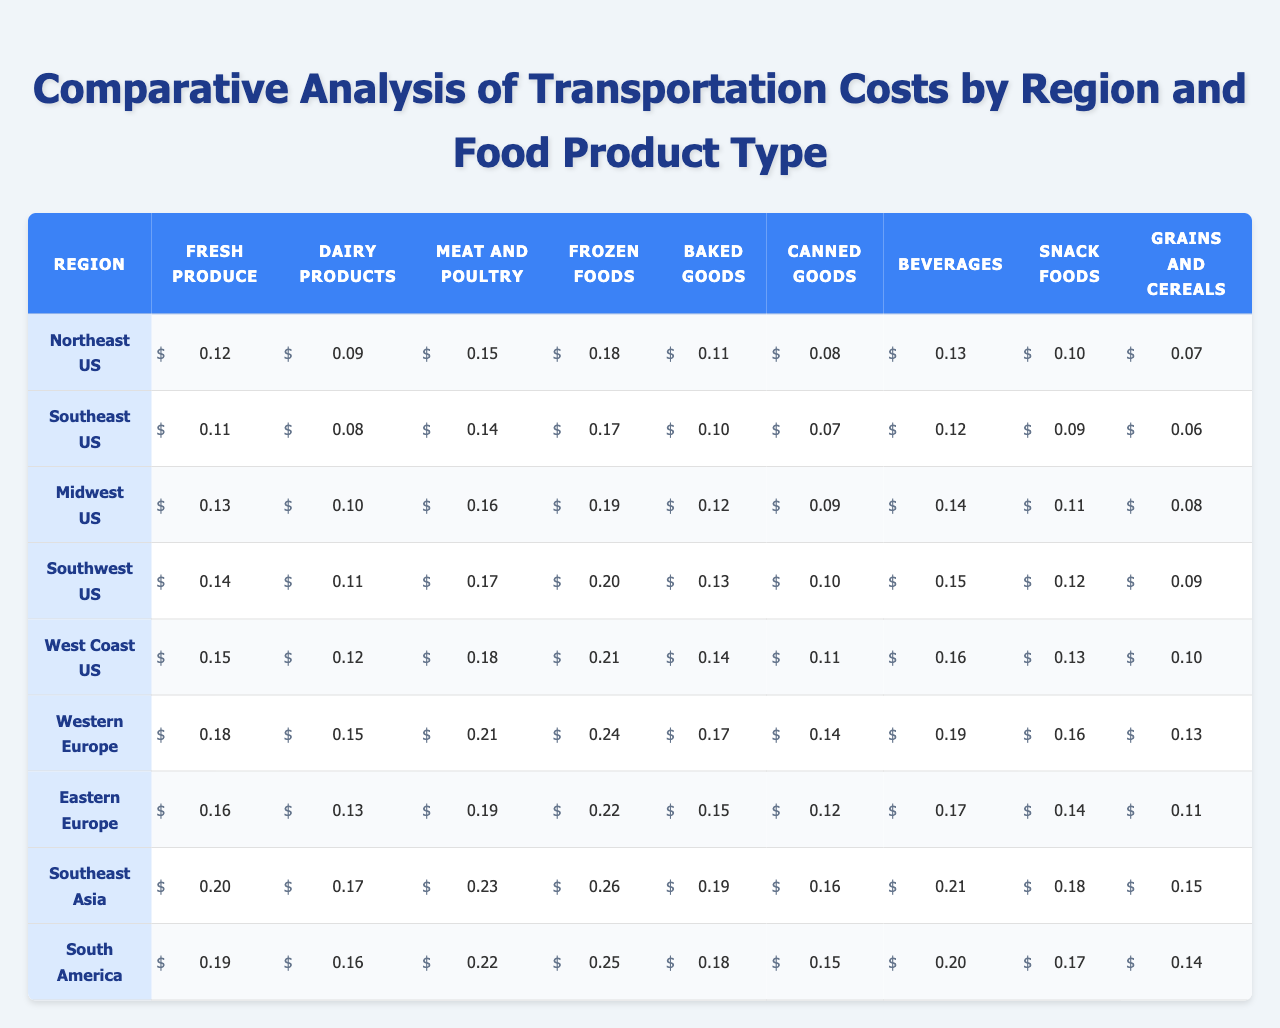What region has the highest transportation cost for Frozen Foods? In the table, we look for the row with the highest value under the "Frozen Foods" column. The "Southeast Asia" region has the highest cost at 0.26.
Answer: Southeast Asia What is the transportation cost for Dairy Products in the Midwestern US? The table indicates that the transportation cost for Dairy Products in the "Midwest US" region is 0.10.
Answer: 0.10 Which food product type has the lowest transportation cost in the Western Europe region? By examining the "Western Europe" row, we see that "Grains and Cereals" has the lowest transportation cost at 0.13.
Answer: Grains and Cereals Is the transportation cost for Baked Goods in the Northeast US higher than in the Southeast US? The table shows that the cost in the Northeast US is 0.11 and in Southeast US is 0.10. Since 0.11 is greater than 0.10, the answer is yes.
Answer: Yes What is the average transportation cost for Meat and Poultry across all regions? To find the average, we sum the values for Meat and Poultry: (0.15 + 0.14 + 0.16 + 0.17 + 0.18 + 0.21 + 0.19 + 0.23 + 0.22) = 1.45. There are 9 regions, so we divide by 9 to get an average of 1.45 / 9 = 0.1611, which rounds to 0.16.
Answer: 0.16 Which region has the highest transportation cost for Snack Foods? By examining the column for Snack Foods, we find that "Southeast Asia" shows a cost of 0.18, which is higher than others.
Answer: Southeast Asia Does the transportation cost for Canned Goods in South America exceed that in the Midwest US? The cost for Canned Goods in South America is 0.15, while in the Midwest US, it's 0.09. Since 0.15 is greater than 0.09, the answer is yes.
Answer: Yes What are the two regions with the lowest transportation costs for Fresh Produce? Looking at the Fresh Produce column, we identify the regions: Southeast US (0.11) and Midwest US (0.13), which are the lowest values.
Answer: Southeast US and Midwest US What is the difference in transportation costs for Frozen Foods between the West Coast US and Western Europe? The difference is calculated as follows: 0.21 (West Coast US) - 0.24 (Western Europe) = -0.03, meaning Western Europe costs 0.03 more.
Answer: 0.03 Which food product type has consistently higher transportation costs across all regions? By analyzing each row, we note that "Frozen Foods" has the highest values in almost all regions compared to other products, indicating consistent higher costs.
Answer: Frozen Foods 